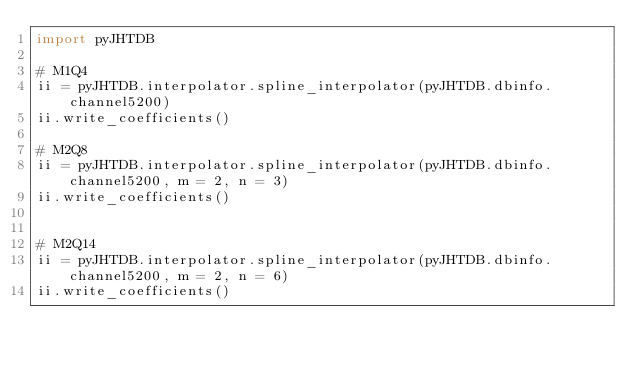Convert code to text. <code><loc_0><loc_0><loc_500><loc_500><_Python_>import pyJHTDB

# M1Q4
ii = pyJHTDB.interpolator.spline_interpolator(pyJHTDB.dbinfo.channel5200)
ii.write_coefficients()

# M2Q8
ii = pyJHTDB.interpolator.spline_interpolator(pyJHTDB.dbinfo.channel5200, m = 2, n = 3)
ii.write_coefficients()


# M2Q14
ii = pyJHTDB.interpolator.spline_interpolator(pyJHTDB.dbinfo.channel5200, m = 2, n = 6)
ii.write_coefficients()

</code> 